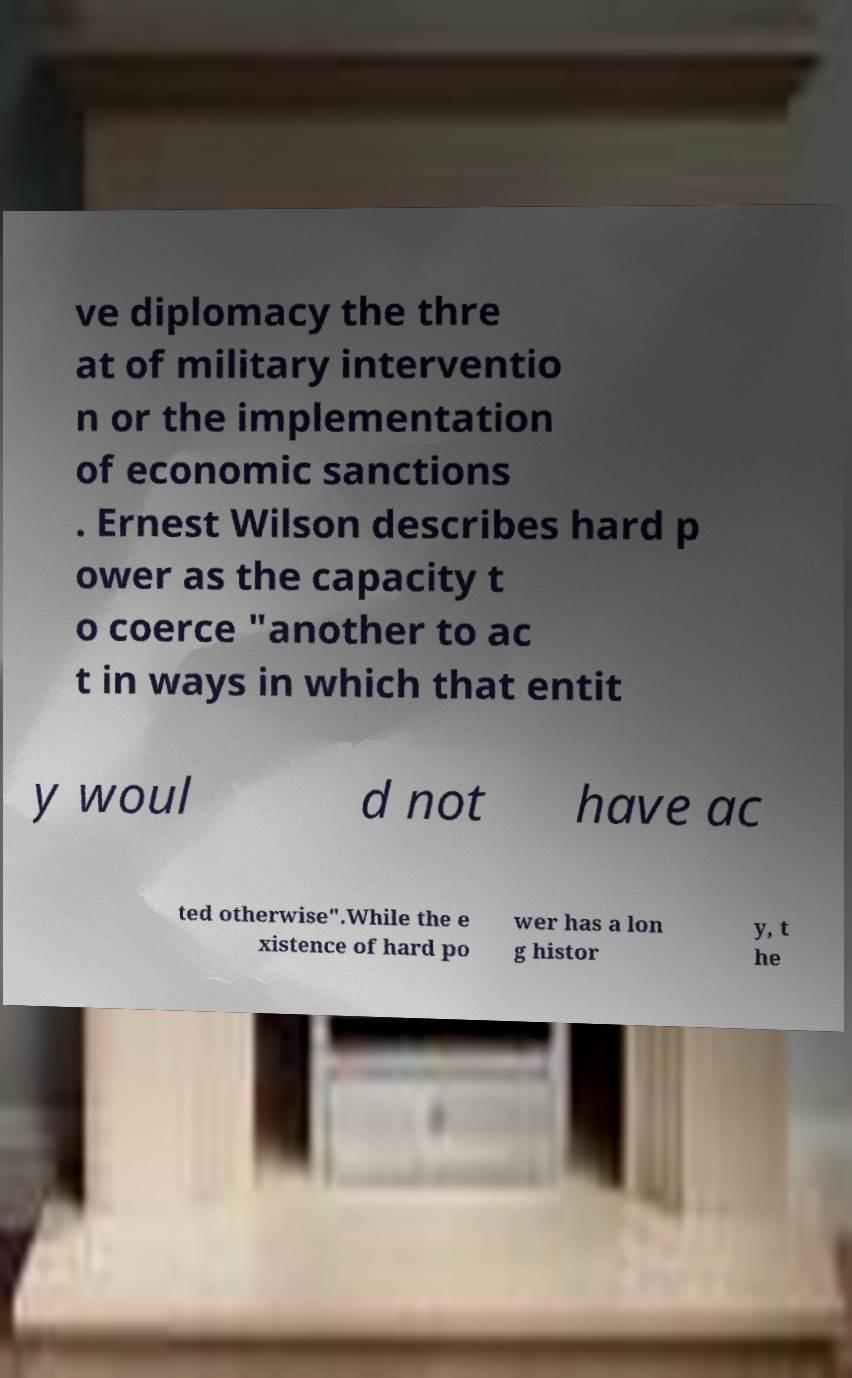I need the written content from this picture converted into text. Can you do that? ve diplomacy the thre at of military interventio n or the implementation of economic sanctions . Ernest Wilson describes hard p ower as the capacity t o coerce "another to ac t in ways in which that entit y woul d not have ac ted otherwise".While the e xistence of hard po wer has a lon g histor y, t he 